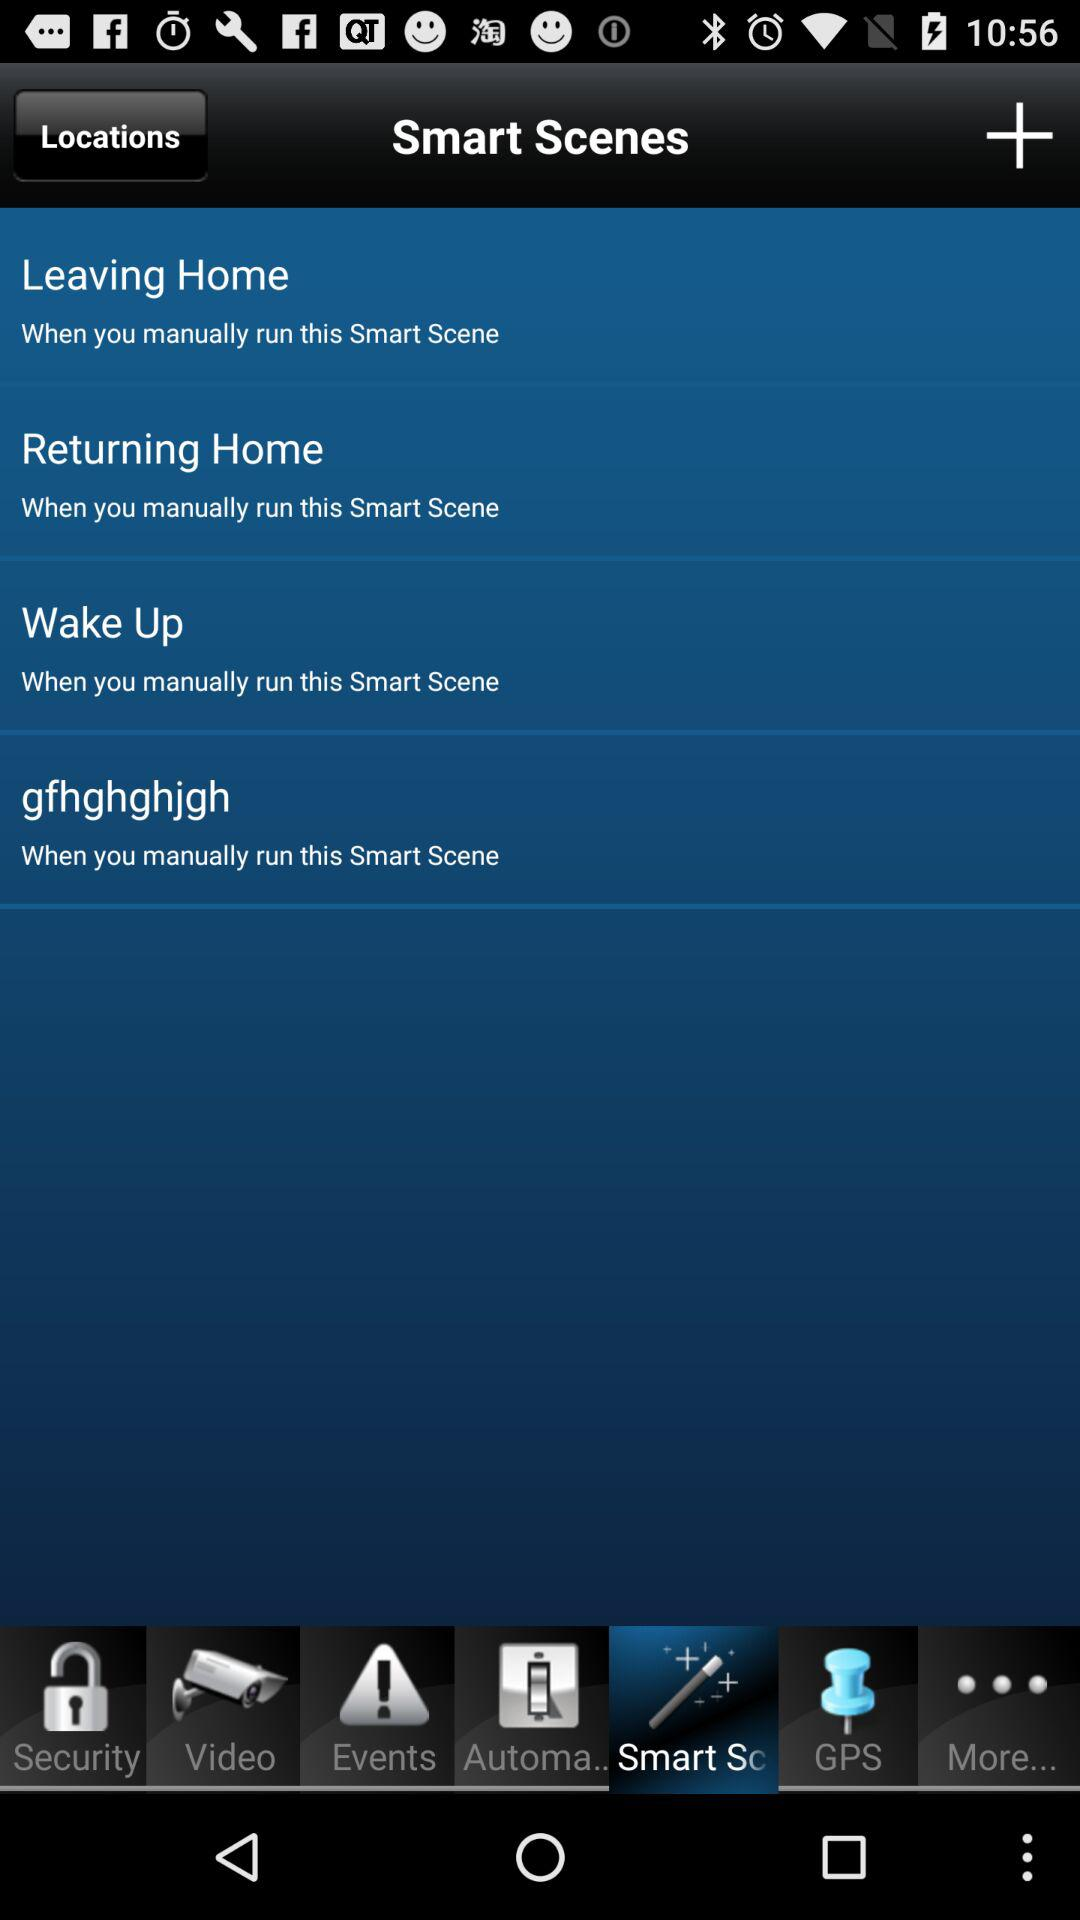How many Smart Scenes are there?
Answer the question using a single word or phrase. 4 